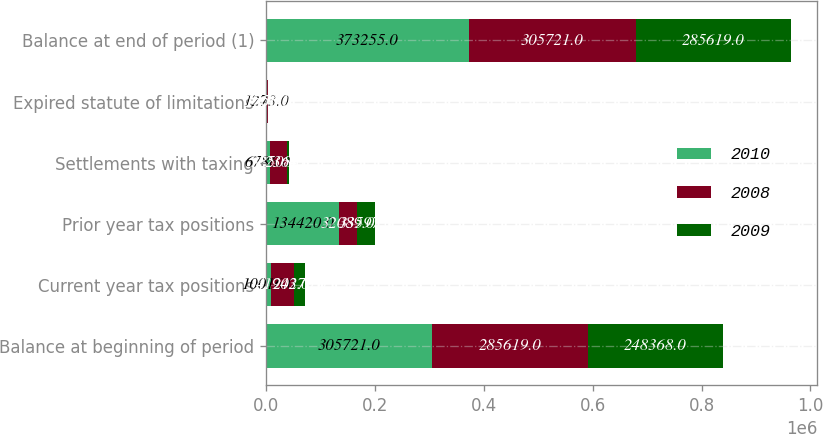Convert chart to OTSL. <chart><loc_0><loc_0><loc_500><loc_500><stacked_bar_chart><ecel><fcel>Balance at beginning of period<fcel>Current year tax positions<fcel>Prior year tax positions<fcel>Settlements with taxing<fcel>Expired statute of limitations<fcel>Balance at end of period (1)<nl><fcel>2010<fcel>305721<fcel>10016<fcel>134420<fcel>6786<fcel>1273<fcel>373255<nl><fcel>2008<fcel>285619<fcel>41943<fcel>32089<fcel>32508<fcel>1703<fcel>305721<nl><fcel>2009<fcel>248368<fcel>20270<fcel>33597<fcel>2364<fcel>1556<fcel>285619<nl></chart> 